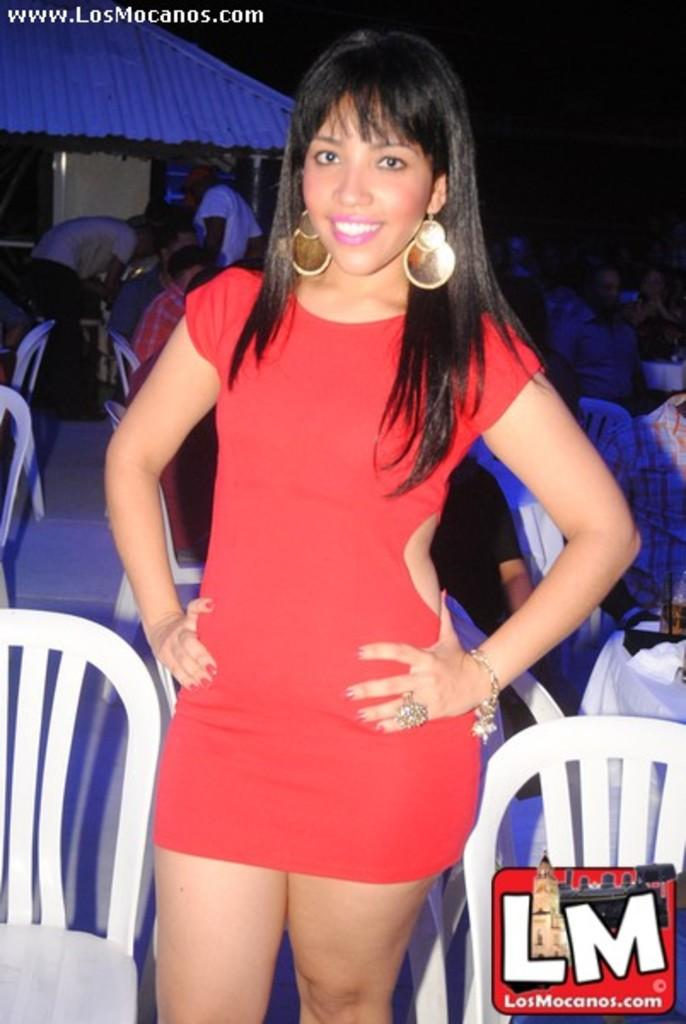Provide a one-sentence caption for the provided image. A girl wearing a red dress stands in front of a bar called Los Mocanos. 